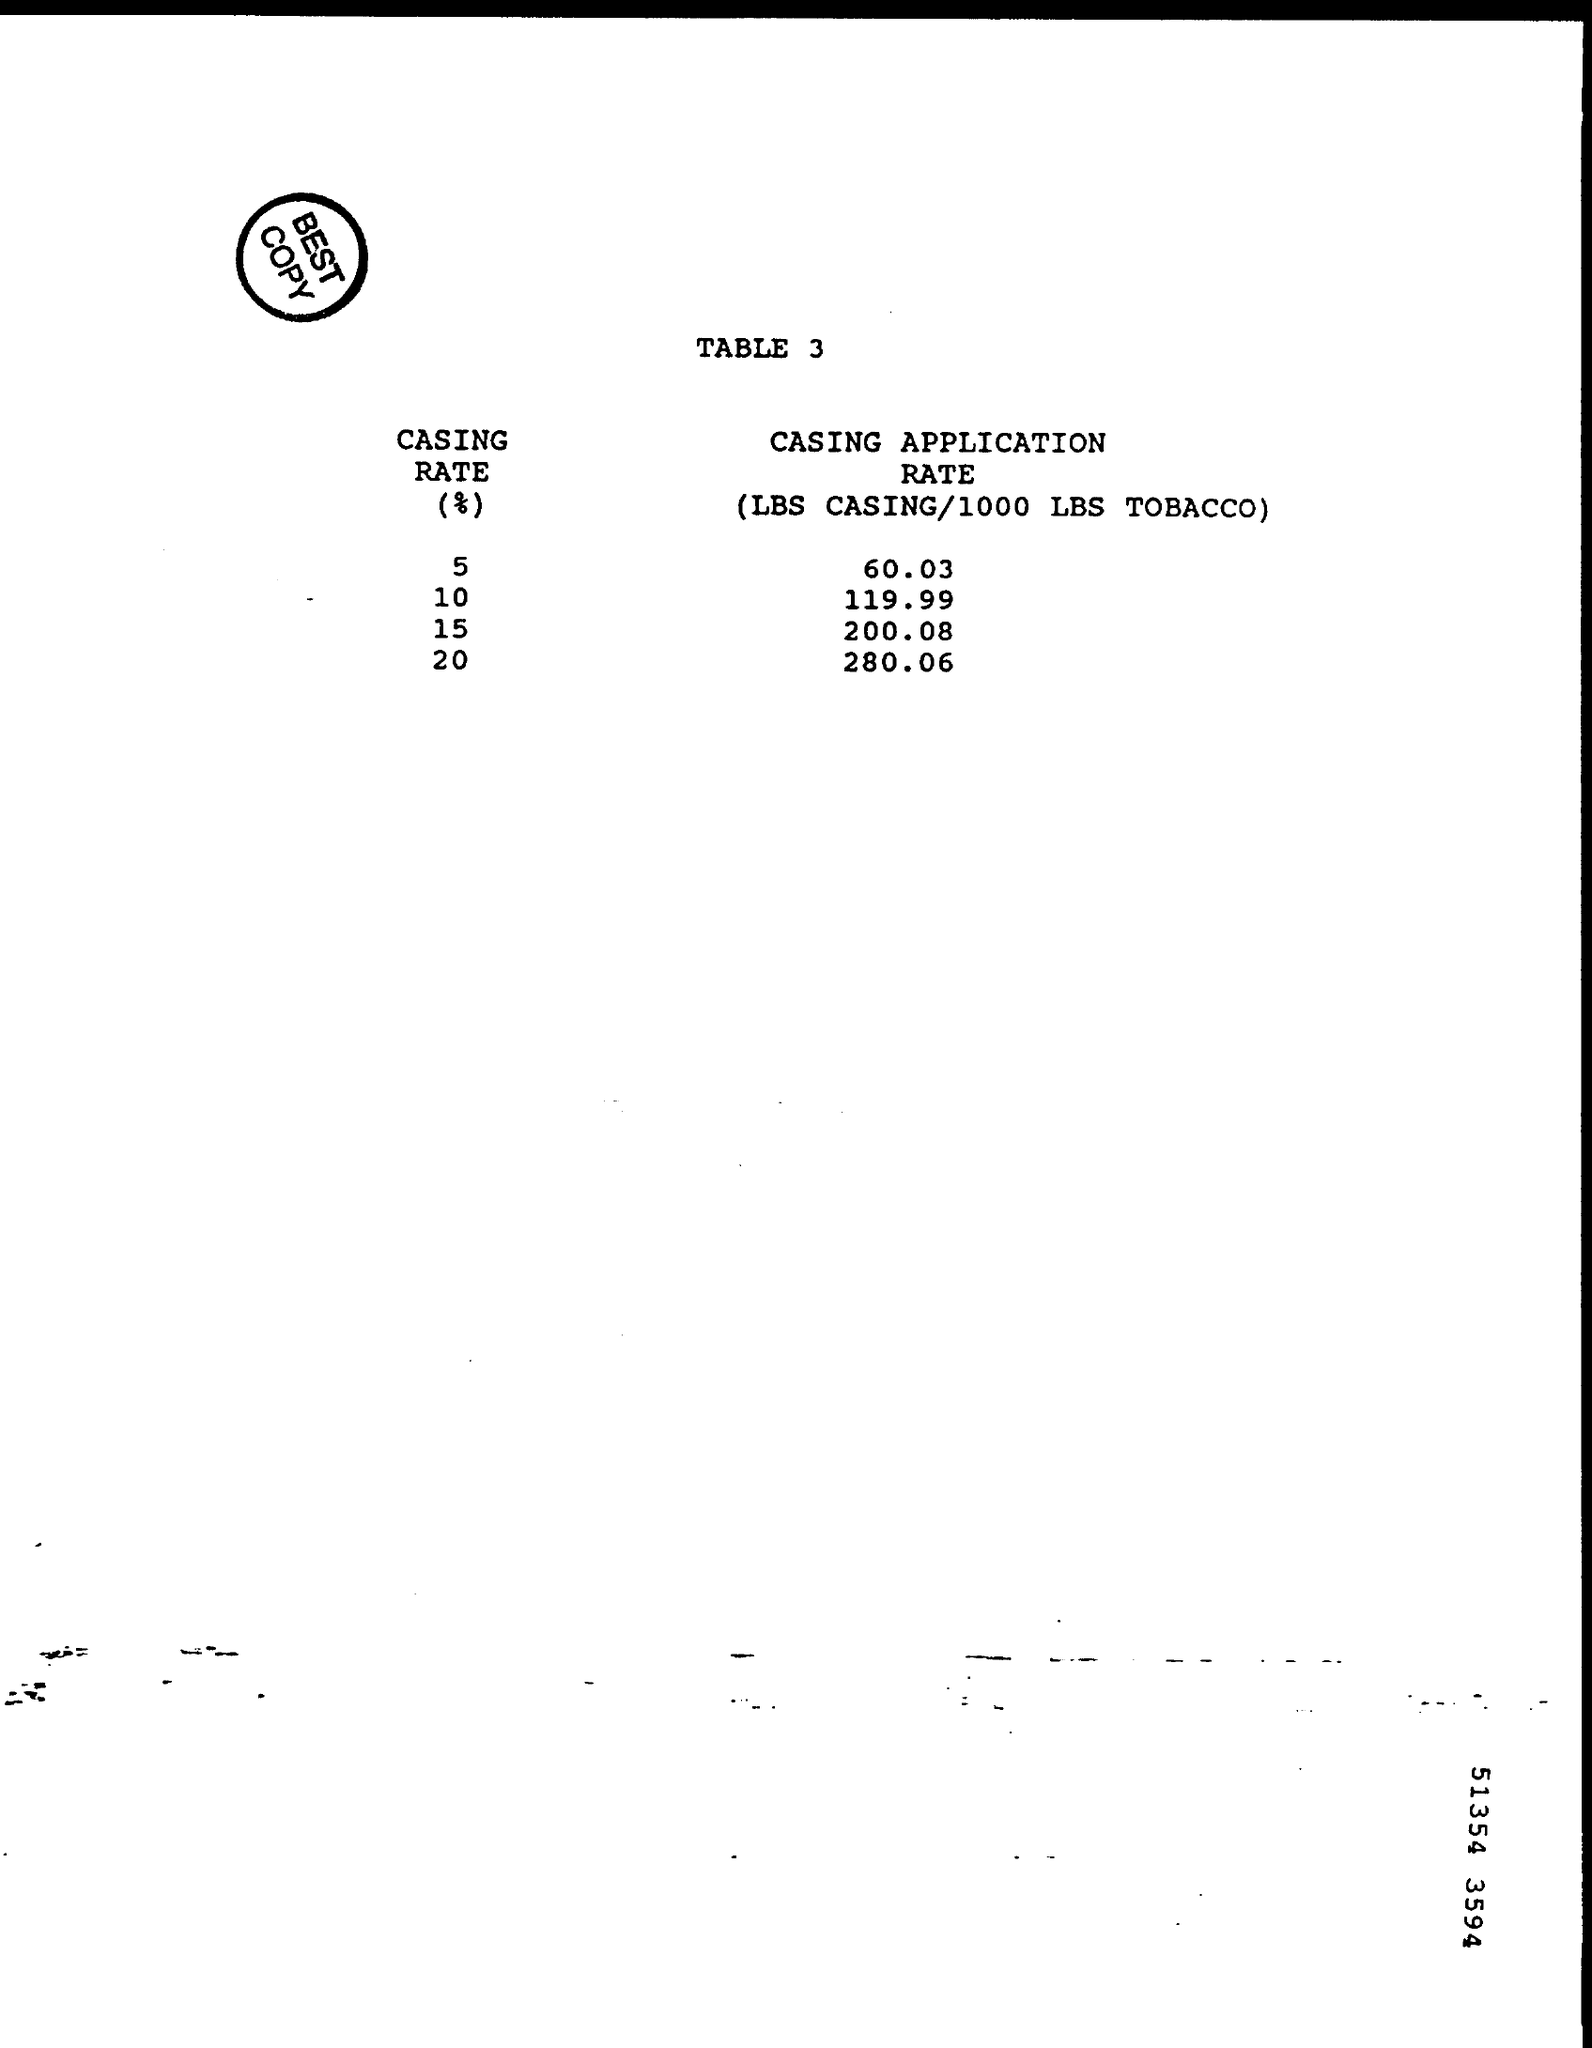What is written inside the circle?
Offer a very short reply. Best Copy. What is the heading of the document?
Ensure brevity in your answer.  Table 3. What is the CASING RATE of CASING APPLICATION 280.06?
Provide a short and direct response. 20%. 